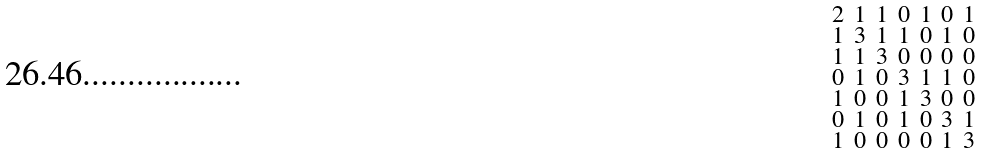Convert formula to latex. <formula><loc_0><loc_0><loc_500><loc_500>\begin{smallmatrix} 2 & 1 & 1 & 0 & 1 & 0 & 1 \\ 1 & 3 & 1 & 1 & 0 & 1 & 0 \\ 1 & 1 & 3 & 0 & 0 & 0 & 0 \\ 0 & 1 & 0 & 3 & 1 & 1 & 0 \\ 1 & 0 & 0 & 1 & 3 & 0 & 0 \\ 0 & 1 & 0 & 1 & 0 & 3 & 1 \\ 1 & 0 & 0 & 0 & 0 & 1 & 3 \end{smallmatrix}</formula> 